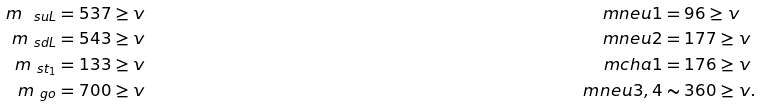Convert formula to latex. <formula><loc_0><loc_0><loc_500><loc_500>m _ { \ s u L } & = 5 3 7 \geq v & \quad \ m n e u { 1 } & = 9 6 \geq v \\ m _ { \ s d L } & = 5 4 3 \geq v & \ m n e u { 2 } & = 1 7 7 \geq v \\ m _ { \ s t _ { 1 } } & = 1 3 3 \geq v & \ m c h a { 1 } & = 1 7 6 \geq v \\ m _ { \ g o } & = 7 0 0 \geq v & \ m n e u { 3 , 4 } & \sim 3 6 0 \geq v .</formula> 